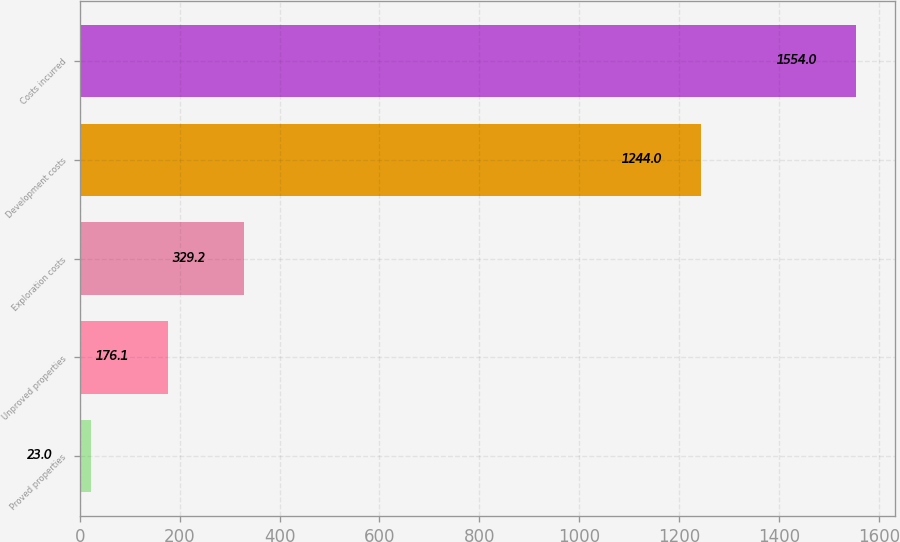Convert chart. <chart><loc_0><loc_0><loc_500><loc_500><bar_chart><fcel>Proved properties<fcel>Unproved properties<fcel>Exploration costs<fcel>Development costs<fcel>Costs incurred<nl><fcel>23<fcel>176.1<fcel>329.2<fcel>1244<fcel>1554<nl></chart> 